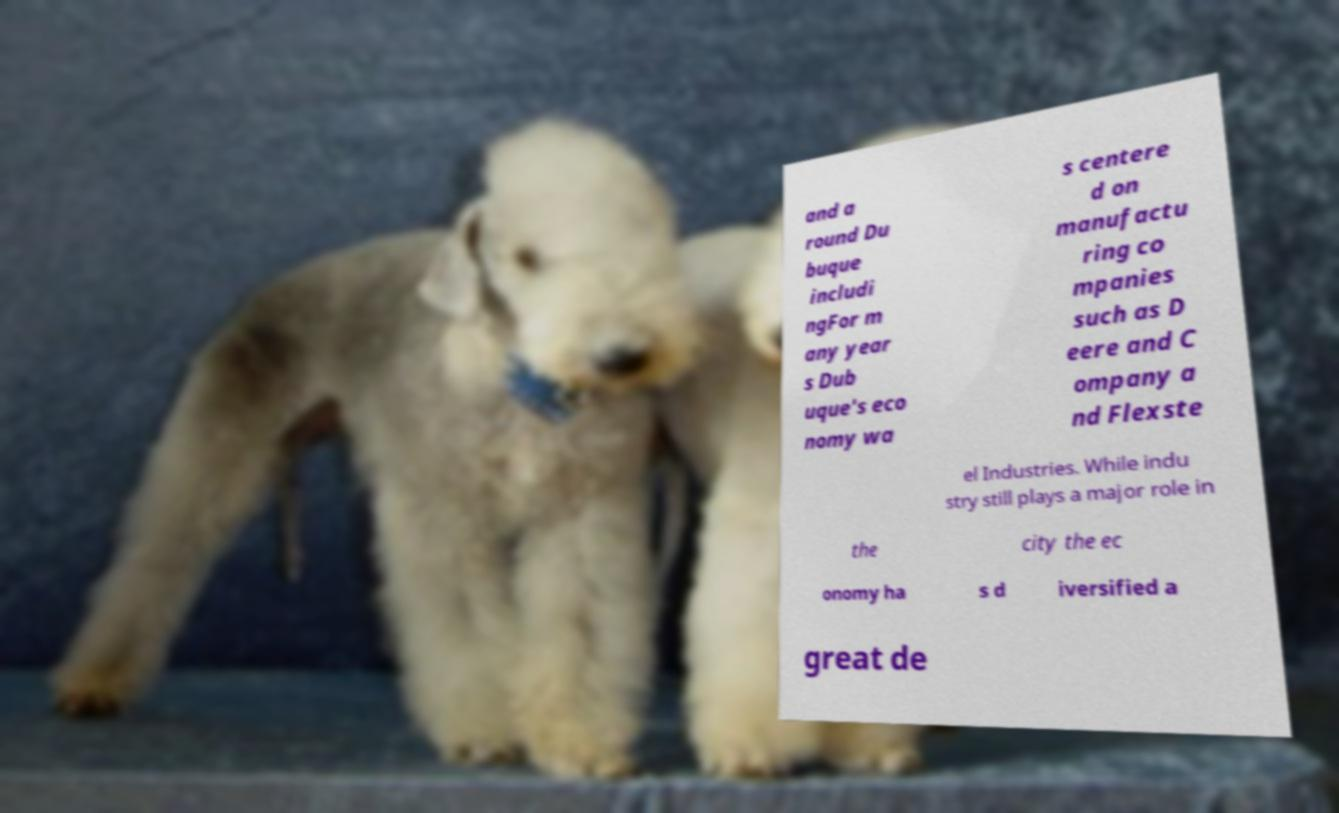What messages or text are displayed in this image? I need them in a readable, typed format. and a round Du buque includi ngFor m any year s Dub uque's eco nomy wa s centere d on manufactu ring co mpanies such as D eere and C ompany a nd Flexste el Industries. While indu stry still plays a major role in the city the ec onomy ha s d iversified a great de 